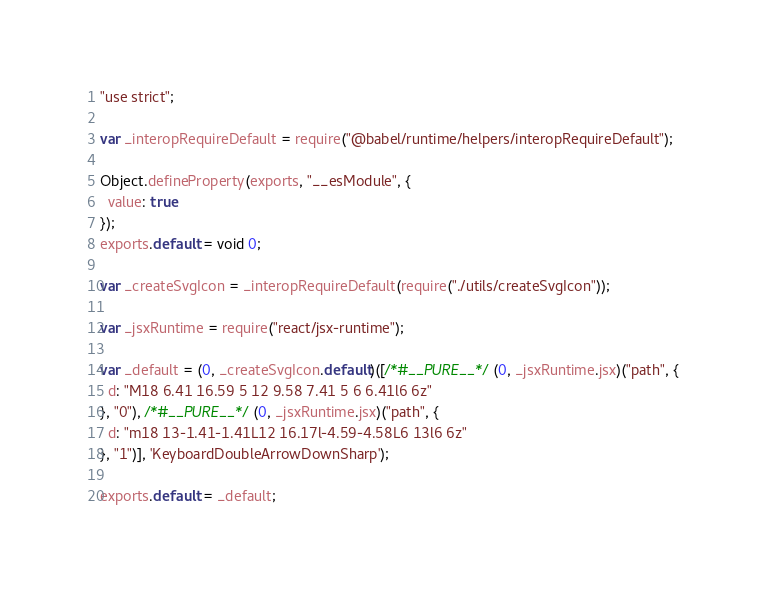<code> <loc_0><loc_0><loc_500><loc_500><_JavaScript_>"use strict";

var _interopRequireDefault = require("@babel/runtime/helpers/interopRequireDefault");

Object.defineProperty(exports, "__esModule", {
  value: true
});
exports.default = void 0;

var _createSvgIcon = _interopRequireDefault(require("./utils/createSvgIcon"));

var _jsxRuntime = require("react/jsx-runtime");

var _default = (0, _createSvgIcon.default)([/*#__PURE__*/(0, _jsxRuntime.jsx)("path", {
  d: "M18 6.41 16.59 5 12 9.58 7.41 5 6 6.41l6 6z"
}, "0"), /*#__PURE__*/(0, _jsxRuntime.jsx)("path", {
  d: "m18 13-1.41-1.41L12 16.17l-4.59-4.58L6 13l6 6z"
}, "1")], 'KeyboardDoubleArrowDownSharp');

exports.default = _default;</code> 